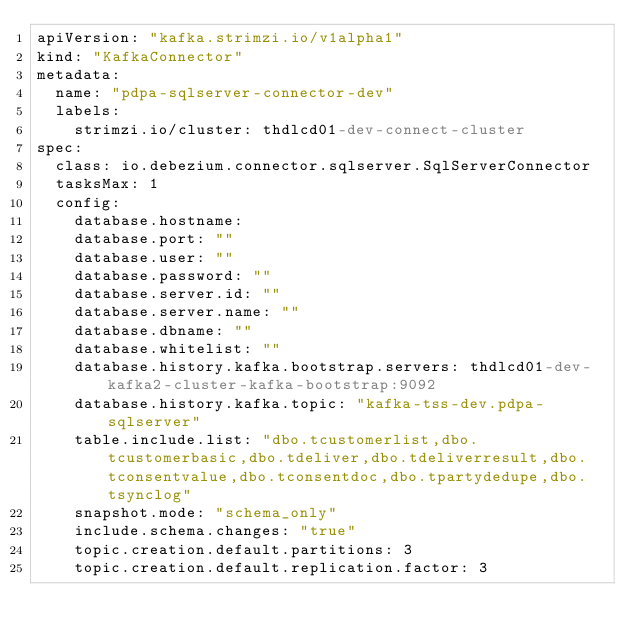Convert code to text. <code><loc_0><loc_0><loc_500><loc_500><_YAML_>apiVersion: "kafka.strimzi.io/v1alpha1"
kind: "KafkaConnector"
metadata:
  name: "pdpa-sqlserver-connector-dev"
  labels:
    strimzi.io/cluster: thdlcd01-dev-connect-cluster
spec:
  class: io.debezium.connector.sqlserver.SqlServerConnector
  tasksMax: 1
  config:
    database.hostname: 
    database.port: ""
    database.user: ""
    database.password: ""
    database.server.id: ""
    database.server.name: ""
    database.dbname: ""
    database.whitelist: ""
    database.history.kafka.bootstrap.servers: thdlcd01-dev-kafka2-cluster-kafka-bootstrap:9092
    database.history.kafka.topic: "kafka-tss-dev.pdpa-sqlserver"
    table.include.list: "dbo.tcustomerlist,dbo.tcustomerbasic,dbo.tdeliver,dbo.tdeliverresult,dbo.tconsentvalue,dbo.tconsentdoc,dbo.tpartydedupe,dbo.tsynclog"
    snapshot.mode: "schema_only"
    include.schema.changes: "true"
    topic.creation.default.partitions: 3
    topic.creation.default.replication.factor: 3
</code> 